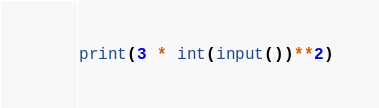<code> <loc_0><loc_0><loc_500><loc_500><_Python_>print(3 * int(input())**2)</code> 